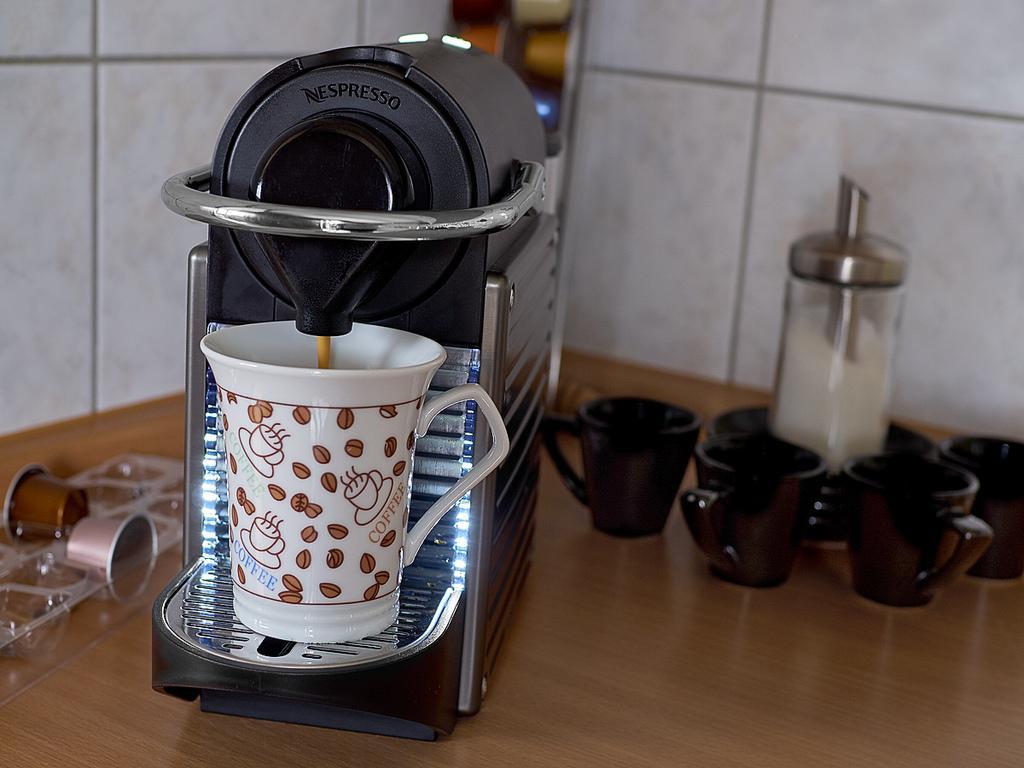Can you describe this image briefly? In this picture there is a coffee machine on the left side of the image and there are cups and a jug of milk in the image. 